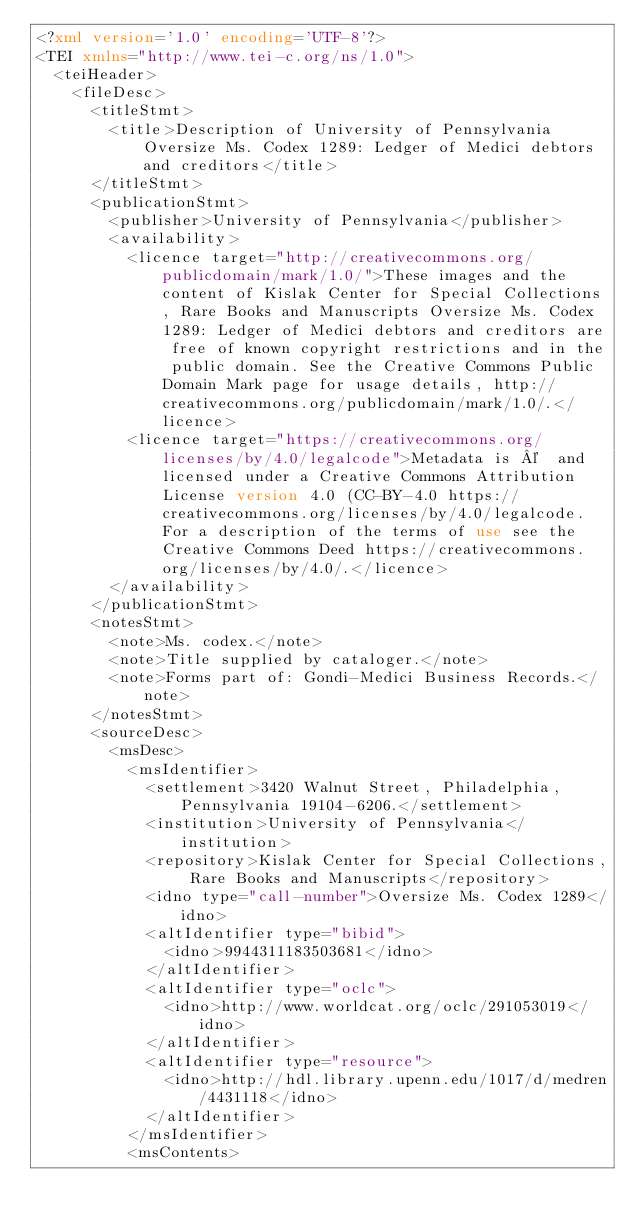Convert code to text. <code><loc_0><loc_0><loc_500><loc_500><_XML_><?xml version='1.0' encoding='UTF-8'?>
<TEI xmlns="http://www.tei-c.org/ns/1.0">
  <teiHeader>
    <fileDesc>
      <titleStmt>
        <title>Description of University of Pennsylvania Oversize Ms. Codex 1289: Ledger of Medici debtors and creditors</title>
      </titleStmt>
      <publicationStmt>
        <publisher>University of Pennsylvania</publisher>
        <availability>
          <licence target="http://creativecommons.org/publicdomain/mark/1.0/">These images and the content of Kislak Center for Special Collections, Rare Books and Manuscripts Oversize Ms. Codex 1289: Ledger of Medici debtors and creditors are free of known copyright restrictions and in the public domain. See the Creative Commons Public Domain Mark page for usage details, http://creativecommons.org/publicdomain/mark/1.0/.</licence>
          <licence target="https://creativecommons.org/licenses/by/4.0/legalcode">Metadata is ©  and licensed under a Creative Commons Attribution License version 4.0 (CC-BY-4.0 https://creativecommons.org/licenses/by/4.0/legalcode. For a description of the terms of use see the Creative Commons Deed https://creativecommons.org/licenses/by/4.0/.</licence>
        </availability>
      </publicationStmt>
      <notesStmt>
        <note>Ms. codex.</note>
        <note>Title supplied by cataloger.</note>
        <note>Forms part of: Gondi-Medici Business Records.</note>
      </notesStmt>
      <sourceDesc>
        <msDesc>
          <msIdentifier>
            <settlement>3420 Walnut Street, Philadelphia, Pennsylvania 19104-6206.</settlement>
            <institution>University of Pennsylvania</institution>
            <repository>Kislak Center for Special Collections, Rare Books and Manuscripts</repository>
            <idno type="call-number">Oversize Ms. Codex 1289</idno>
            <altIdentifier type="bibid">
              <idno>9944311183503681</idno>
            </altIdentifier>
            <altIdentifier type="oclc">
              <idno>http://www.worldcat.org/oclc/291053019</idno>
            </altIdentifier>
            <altIdentifier type="resource">
              <idno>http://hdl.library.upenn.edu/1017/d/medren/4431118</idno>
            </altIdentifier>
          </msIdentifier>
          <msContents></code> 